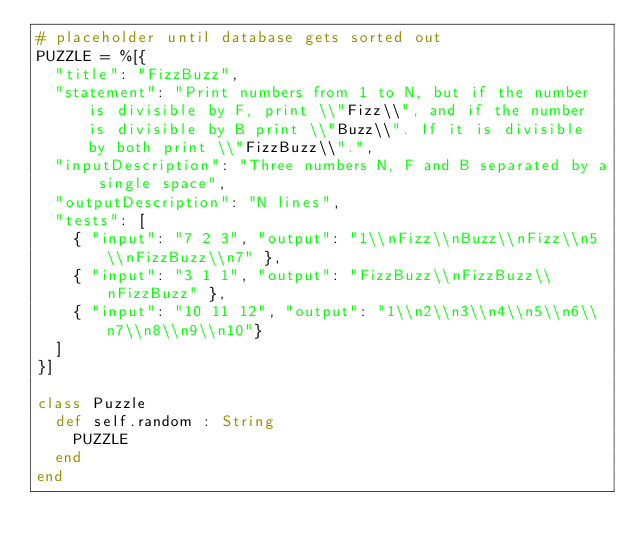Convert code to text. <code><loc_0><loc_0><loc_500><loc_500><_Crystal_># placeholder until database gets sorted out
PUZZLE = %[{
  "title": "FizzBuzz",
  "statement": "Print numbers from 1 to N, but if the number is divisible by F, print \\"Fizz\\", and if the number is divisible by B print \\"Buzz\\". If it is divisible by both print \\"FizzBuzz\\".",
  "inputDescription": "Three numbers N, F and B separated by a single space",
  "outputDescription": "N lines",
  "tests": [
    { "input": "7 2 3", "output": "1\\nFizz\\nBuzz\\nFizz\\n5\\nFizzBuzz\\n7" },
    { "input": "3 1 1", "output": "FizzBuzz\\nFizzBuzz\\nFizzBuzz" },
    { "input": "10 11 12", "output": "1\\n2\\n3\\n4\\n5\\n6\\n7\\n8\\n9\\n10"}
  ]
}]

class Puzzle
  def self.random : String
    PUZZLE
  end
end
</code> 